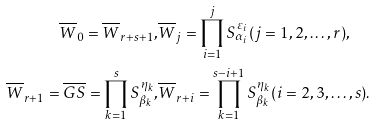Convert formula to latex. <formula><loc_0><loc_0><loc_500><loc_500>\overline { W } _ { 0 } = \overline { W } _ { r + s + 1 } , & \overline { W } _ { j } = \prod ^ { j } _ { i = 1 } S ^ { \varepsilon _ { i } } _ { \alpha _ { i } } ( j = 1 , 2 , \dots , r ) , \\ \overline { W } _ { r + 1 } = \overline { G S } = \prod ^ { s } _ { k = 1 } S ^ { \eta _ { k } } _ { \beta _ { k } } , & \overline { W } _ { r + i } = \prod ^ { s - i + 1 } _ { k = 1 } S ^ { \eta _ { k } } _ { \beta _ { k } } ( i = 2 , 3 , \dots , s ) .</formula> 